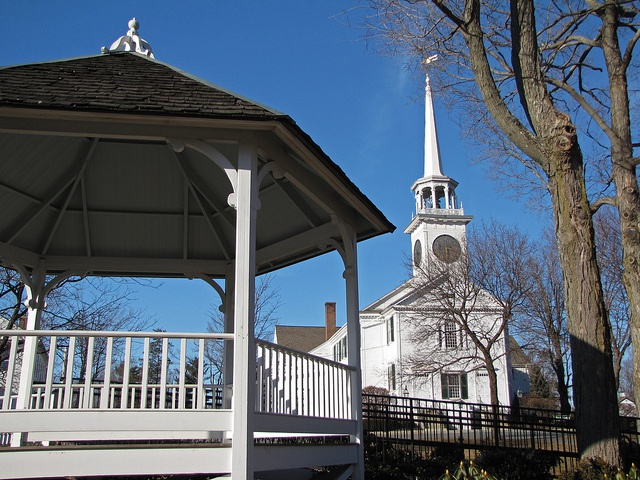Describe the objects in this image and their specific colors. I can see clock in blue, gray, and black tones and clock in blue, gray, darkgray, lightgray, and purple tones in this image. 